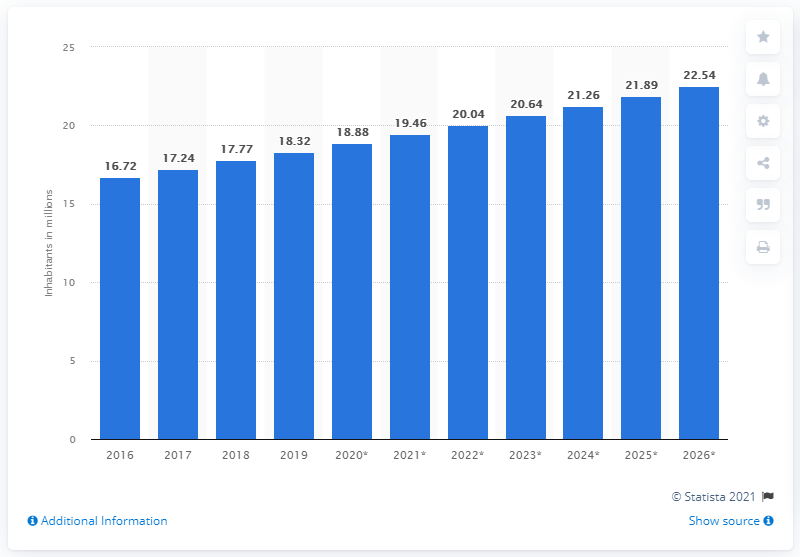Point out several critical features in this image. In 2020, the population of Zambia was 18.88 million. 